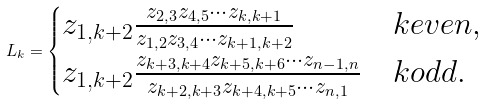Convert formula to latex. <formula><loc_0><loc_0><loc_500><loc_500>L _ { k } = \begin{cases} z _ { 1 , k + 2 } \frac { z _ { 2 , 3 } z _ { 4 , 5 } \cdots z _ { k , k + 1 } } { z _ { 1 , 2 } z _ { 3 , 4 } \cdots z _ { k + 1 , k + 2 } } & k e v e n , \\ z _ { 1 , k + 2 } \frac { z _ { k + 3 , k + 4 } z _ { k + 5 , k + 6 } \cdots z _ { n - 1 , n } } { z _ { k + 2 , k + 3 } z _ { k + 4 , k + 5 } \cdots z _ { n , 1 } } & k o d d . \end{cases}</formula> 